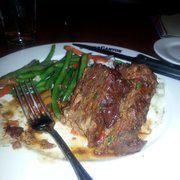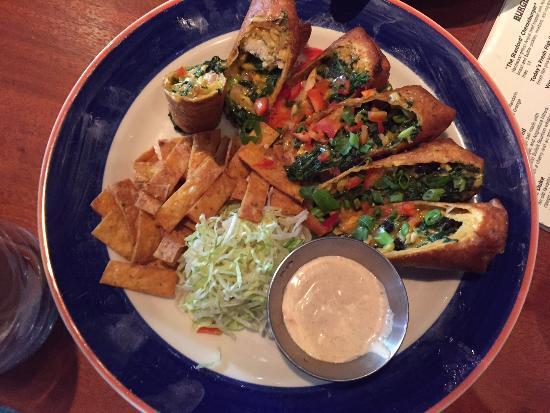The first image is the image on the left, the second image is the image on the right. Assess this claim about the two images: "The food in the image on the right is being served in a blue and white dish.". Correct or not? Answer yes or no. Yes. The first image is the image on the left, the second image is the image on the right. Analyze the images presented: Is the assertion "At least one image shows green beans next to meatloaf on a plate, and one plate has a royal blue band around it rimmed with red." valid? Answer yes or no. Yes. 